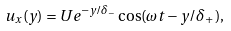<formula> <loc_0><loc_0><loc_500><loc_500>u _ { x } ( y ) = U e ^ { - y / \delta _ { - } } \cos ( \omega t - y / \delta _ { + } ) ,</formula> 